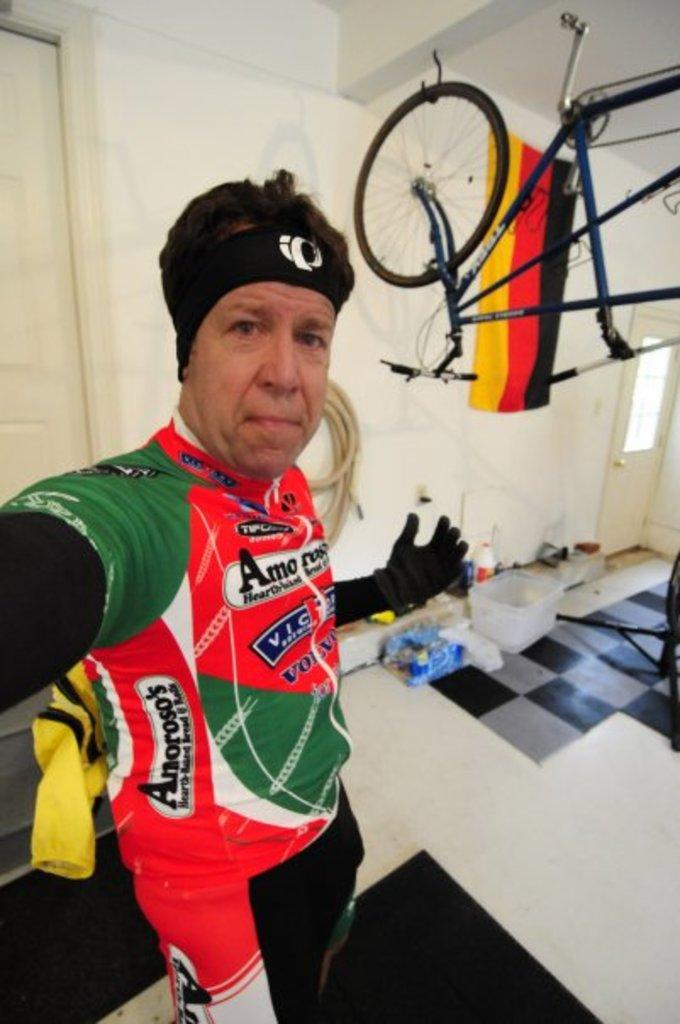Who is present in the image? There is a man in the image. What is the man wearing? The man is wearing a jacket and trousers. What objects can be seen on the floor in the image? There are baskets and bottles on the floor. What mode of transportation is visible in the image? There is a cycle in the image. What symbol or emblem can be seen in the image? There is a flag in the image. What type of structure is present in the image? There is a wall in the image. What type of receipt can be seen on the wall in the image? There is no receipt present on the wall in the image. What type of thunder can be heard in the image? There is no sound, including thunder, present in the image, as it is a still photograph. 